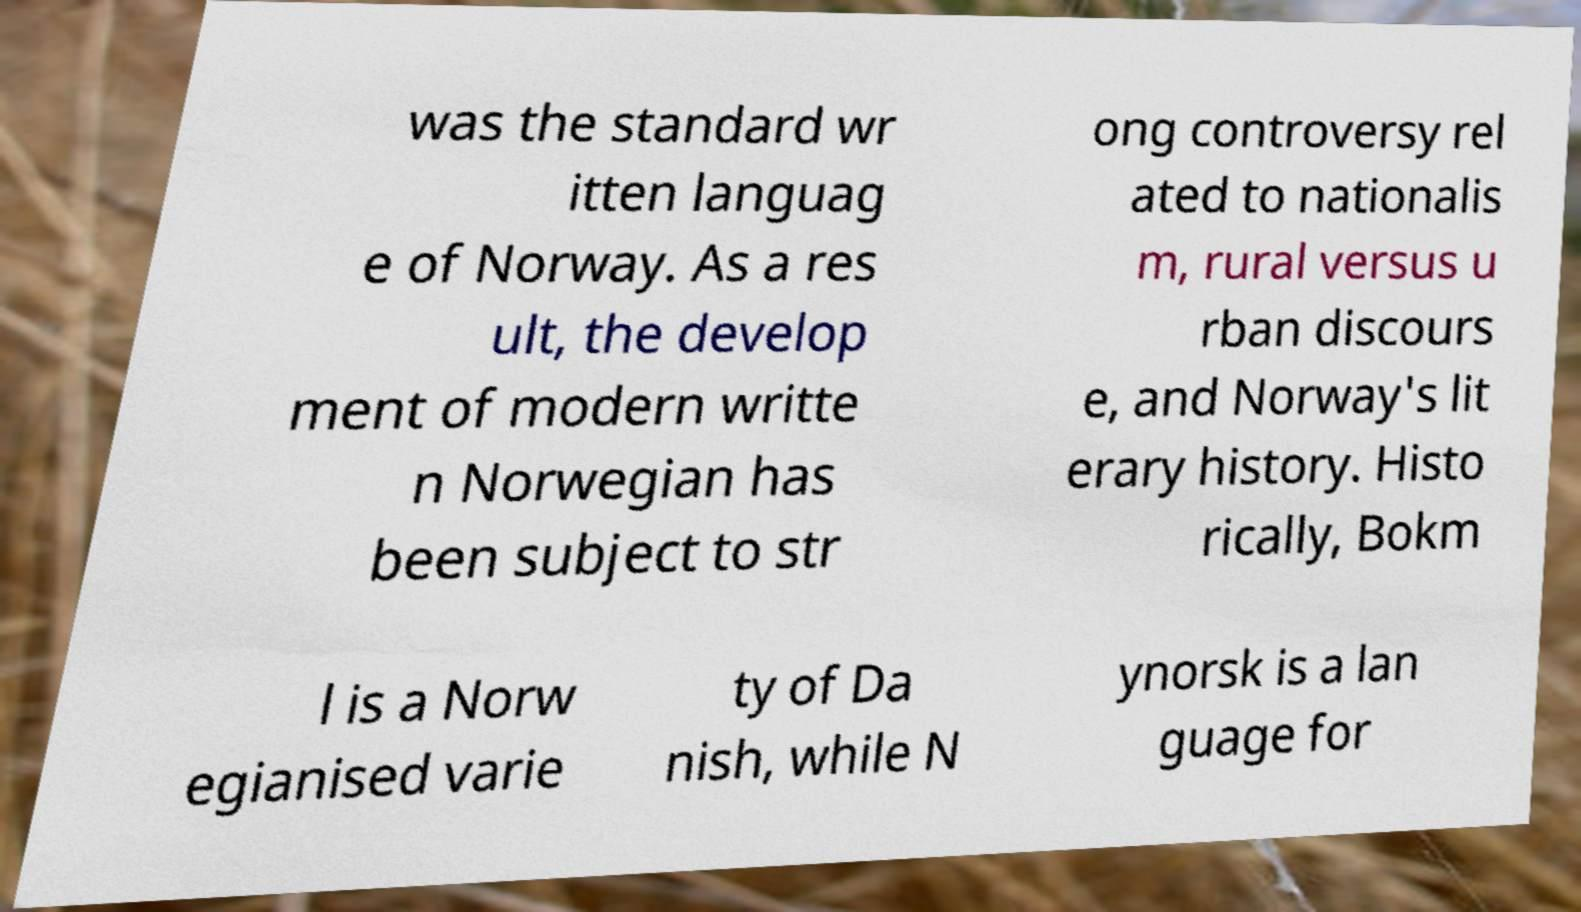Can you read and provide the text displayed in the image?This photo seems to have some interesting text. Can you extract and type it out for me? was the standard wr itten languag e of Norway. As a res ult, the develop ment of modern writte n Norwegian has been subject to str ong controversy rel ated to nationalis m, rural versus u rban discours e, and Norway's lit erary history. Histo rically, Bokm l is a Norw egianised varie ty of Da nish, while N ynorsk is a lan guage for 